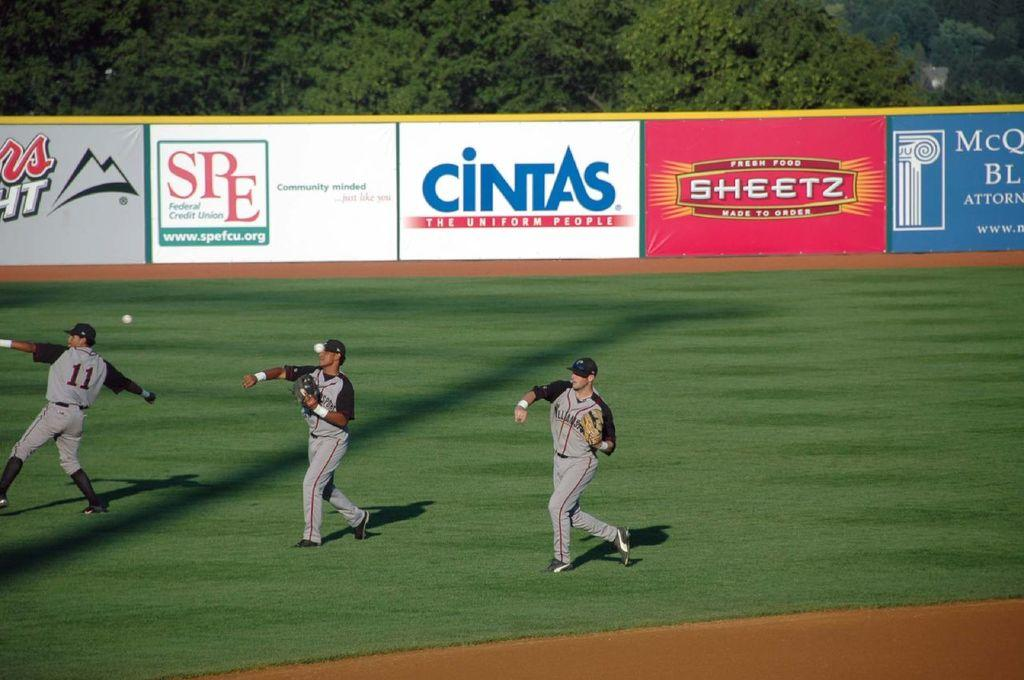<image>
Present a compact description of the photo's key features. Ads for Coors Light, Cintas, SPE and Sheetz cover the walls of a ballpark. 